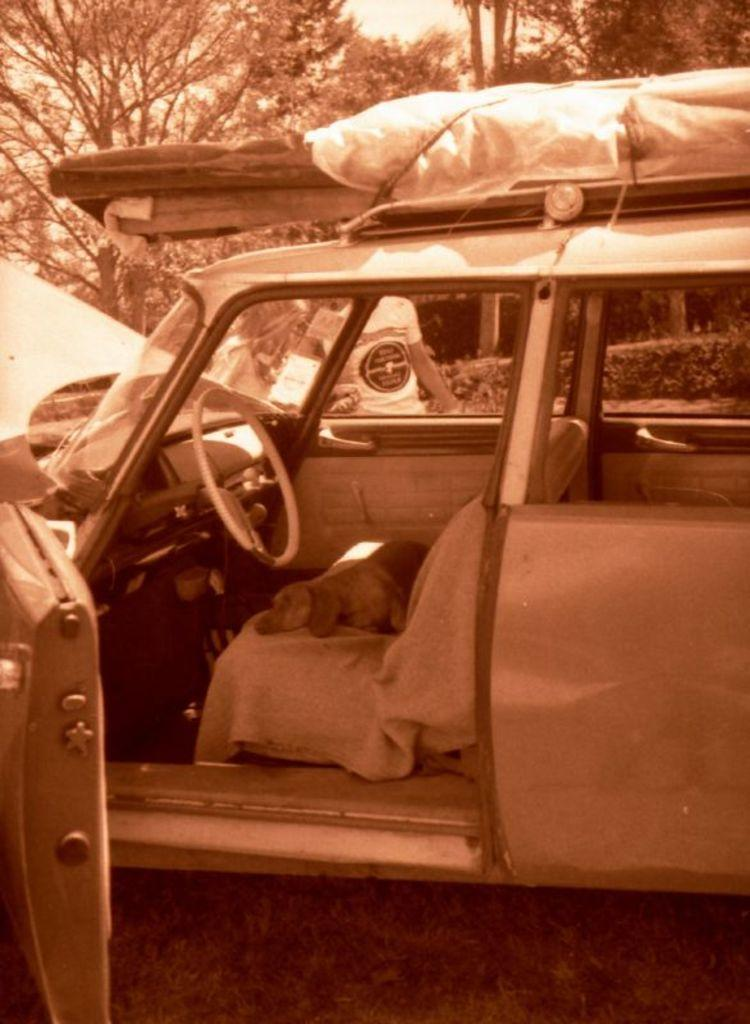What is the color scheme of the image? The image is black and white. What can be seen in the image? There is a vehicle and a dog in the image. Can you describe the background of the image? In the background, there is a person, plants, trees, and the sky visible. What type of basin is being used to brake the vehicle in the image? There is no basin or braking action depicted in the image; it only shows a vehicle and a dog. Can you describe the smashing of the vehicle in the image? There is no smashing of the vehicle in the image; it appears to be stationary. 